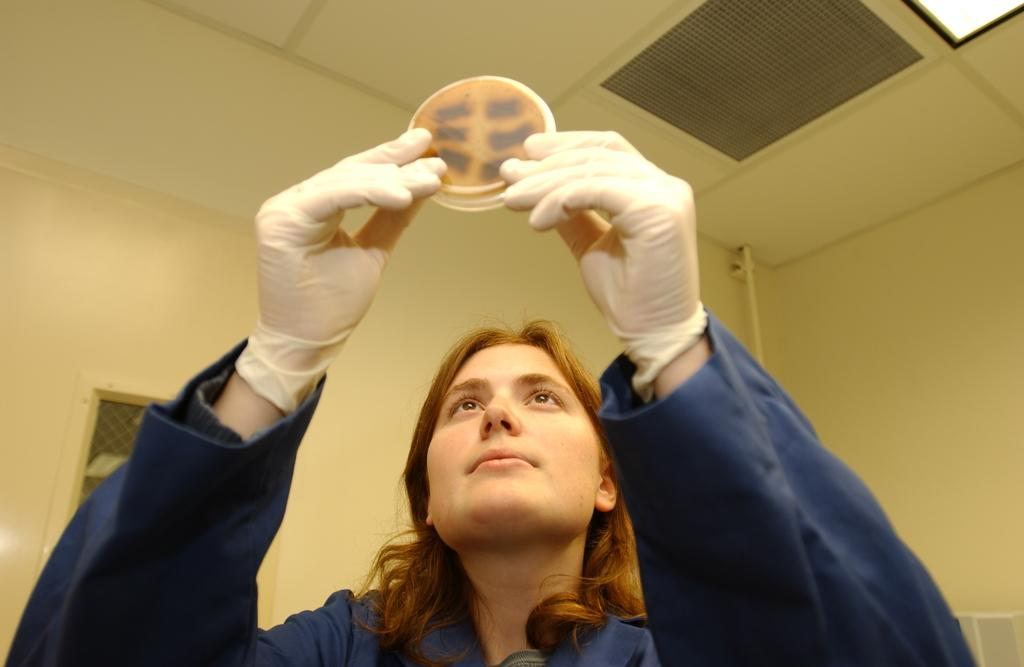Who is present in the image? There is a woman in the image. What is the woman holding in her hands? The woman is holding an object in her hands. What type of clothing is the woman wearing on her hands? The woman is wearing gloves. What can be seen in the background of the image? There is a wall visible in the image. What type of riddle is the woman trying to solve in the image? There is no riddle present in the image; the woman is simply holding an object with her gloved hands. 